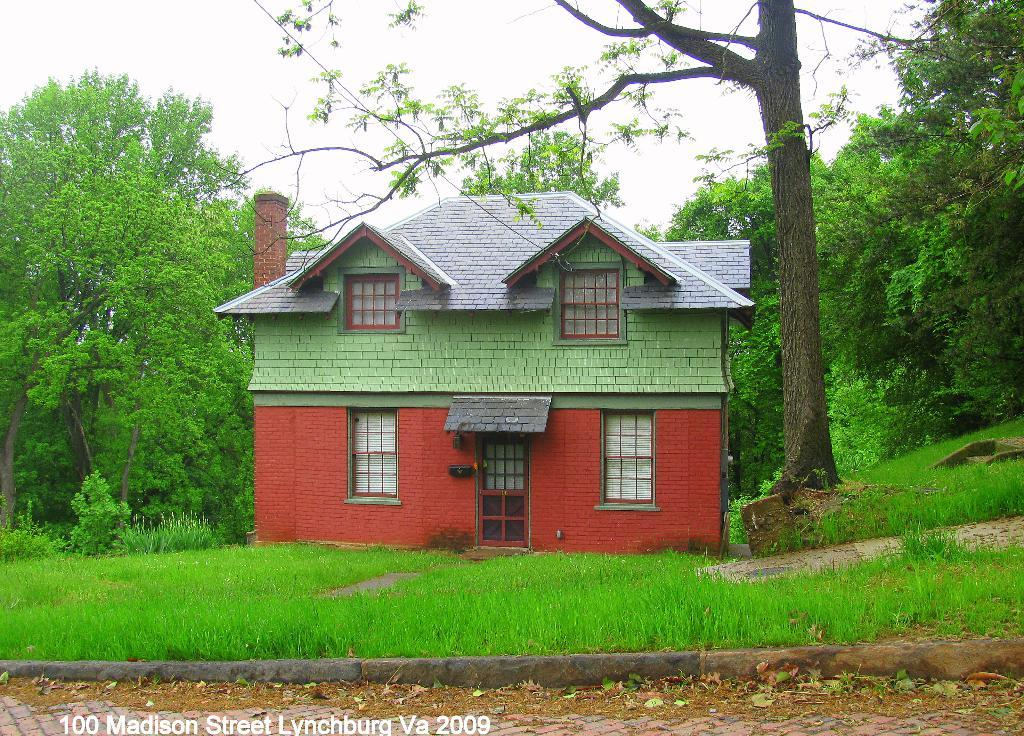What is the main structure in the center of the image? There is a house in the center of the image. What type of vegetation is on the right side of the image? There is a tree on the right side of the image. What is visible at the bottom of the image? Grass and a road are visible at the bottom of the image. What can be seen in the background of the image? There are trees and the sky visible in the background of the image. What type of jewel is embedded in the roof of the house in the image? There is no jewel present in the image, and the roof of the house is not mentioned in the provided facts. 